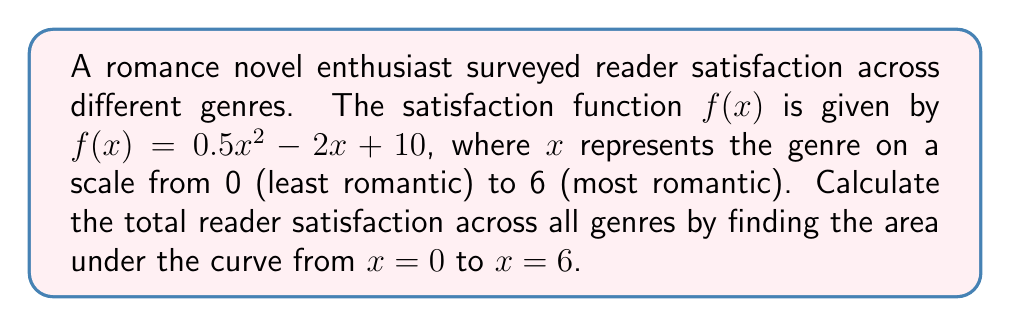Help me with this question. To find the area under the curve, we need to integrate the function $f(x)$ from $x = 0$ to $x = 6$.

Step 1: Set up the definite integral
$$\int_0^6 (0.5x^2 - 2x + 10) dx$$

Step 2: Integrate each term
$\int 0.5x^2 dx = \frac{1}{6}x^3$
$\int -2x dx = -x^2$
$\int 10 dx = 10x$

Step 3: Apply the fundamental theorem of calculus
$$\left[\frac{1}{6}x^3 - x^2 + 10x\right]_0^6$$

Step 4: Evaluate the expression at the upper and lower bounds
Upper bound: $\frac{1}{6}(6^3) - (6^2) + 10(6) = 36 - 36 + 60 = 60$
Lower bound: $\frac{1}{6}(0^3) - (0^2) + 10(0) = 0$

Step 5: Subtract the lower bound from the upper bound
$60 - 0 = 60$

Therefore, the total reader satisfaction across all genres is 60 units.
Answer: 60 units 